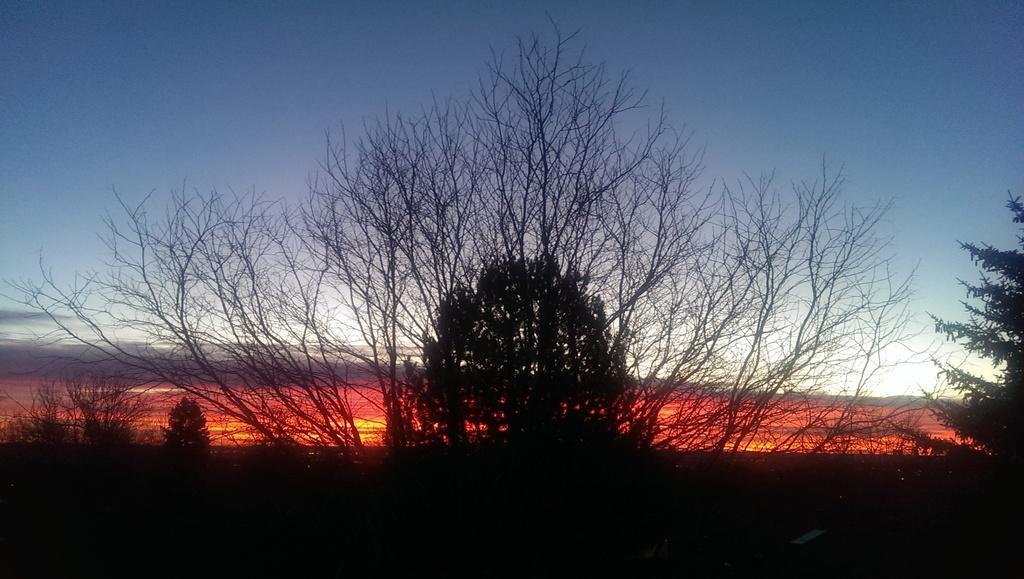Please provide a concise description of this image. In this image we can see the trees and also the sky in the background. 